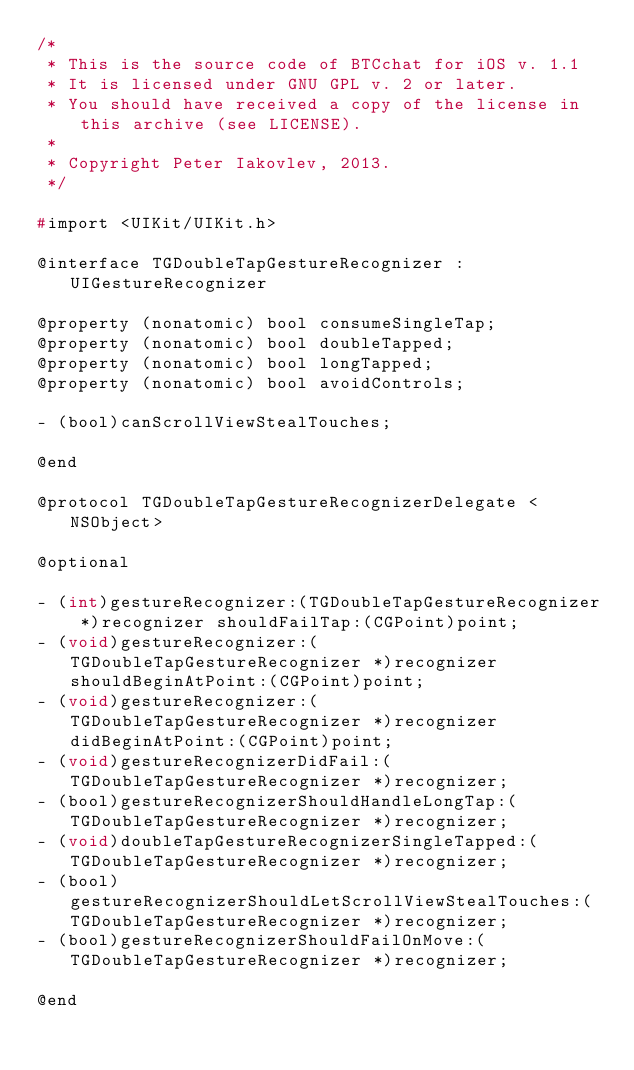Convert code to text. <code><loc_0><loc_0><loc_500><loc_500><_C_>/*
 * This is the source code of BTCchat for iOS v. 1.1
 * It is licensed under GNU GPL v. 2 or later.
 * You should have received a copy of the license in this archive (see LICENSE).
 *
 * Copyright Peter Iakovlev, 2013.
 */

#import <UIKit/UIKit.h>

@interface TGDoubleTapGestureRecognizer : UIGestureRecognizer

@property (nonatomic) bool consumeSingleTap;
@property (nonatomic) bool doubleTapped;
@property (nonatomic) bool longTapped;
@property (nonatomic) bool avoidControls;

- (bool)canScrollViewStealTouches;

@end

@protocol TGDoubleTapGestureRecognizerDelegate <NSObject>

@optional

- (int)gestureRecognizer:(TGDoubleTapGestureRecognizer *)recognizer shouldFailTap:(CGPoint)point;
- (void)gestureRecognizer:(TGDoubleTapGestureRecognizer *)recognizer shouldBeginAtPoint:(CGPoint)point;
- (void)gestureRecognizer:(TGDoubleTapGestureRecognizer *)recognizer didBeginAtPoint:(CGPoint)point;
- (void)gestureRecognizerDidFail:(TGDoubleTapGestureRecognizer *)recognizer;
- (bool)gestureRecognizerShouldHandleLongTap:(TGDoubleTapGestureRecognizer *)recognizer;
- (void)doubleTapGestureRecognizerSingleTapped:(TGDoubleTapGestureRecognizer *)recognizer;
- (bool)gestureRecognizerShouldLetScrollViewStealTouches:(TGDoubleTapGestureRecognizer *)recognizer;
- (bool)gestureRecognizerShouldFailOnMove:(TGDoubleTapGestureRecognizer *)recognizer;

@end
</code> 